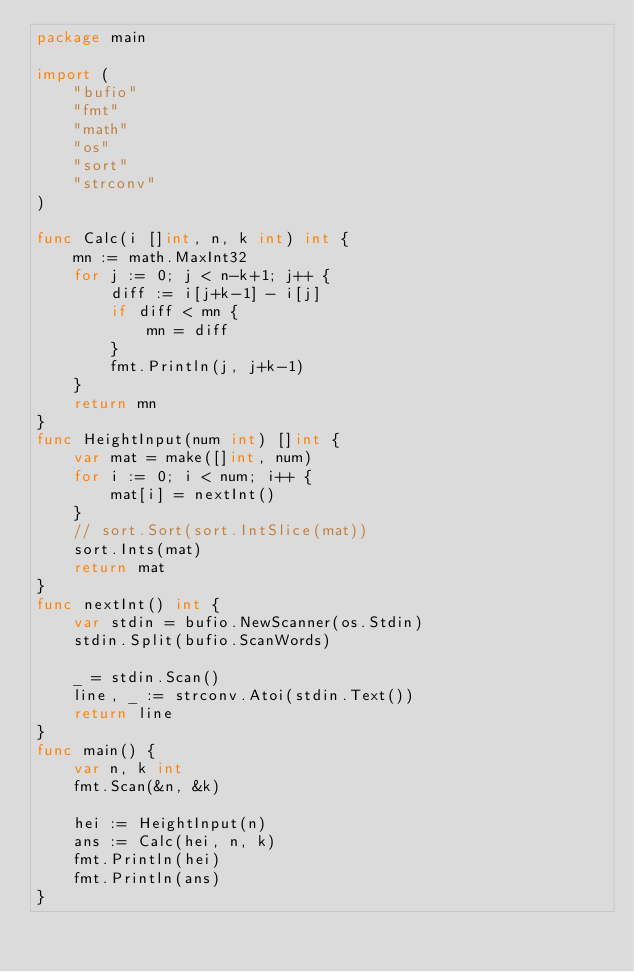<code> <loc_0><loc_0><loc_500><loc_500><_Go_>package main

import (
	"bufio"
	"fmt"
	"math"
	"os"
	"sort"
	"strconv"
)

func Calc(i []int, n, k int) int {
	mn := math.MaxInt32
	for j := 0; j < n-k+1; j++ {
		diff := i[j+k-1] - i[j]
		if diff < mn {
			mn = diff
		}
		fmt.Println(j, j+k-1)
	}
	return mn
}
func HeightInput(num int) []int {
	var mat = make([]int, num)
	for i := 0; i < num; i++ {
		mat[i] = nextInt()
	}
	// sort.Sort(sort.IntSlice(mat))
	sort.Ints(mat)
	return mat
}
func nextInt() int {
	var stdin = bufio.NewScanner(os.Stdin)
	stdin.Split(bufio.ScanWords)

	_ = stdin.Scan()
	line, _ := strconv.Atoi(stdin.Text())
	return line
}
func main() {
	var n, k int
	fmt.Scan(&n, &k)

	hei := HeightInput(n)
	ans := Calc(hei, n, k)
	fmt.Println(hei)
	fmt.Println(ans)
}
</code> 